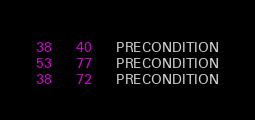Convert code to text. <code><loc_0><loc_0><loc_500><loc_500><_SQL_>38	40	PRECONDITION
53	77	PRECONDITION
38	72	PRECONDITION
</code> 